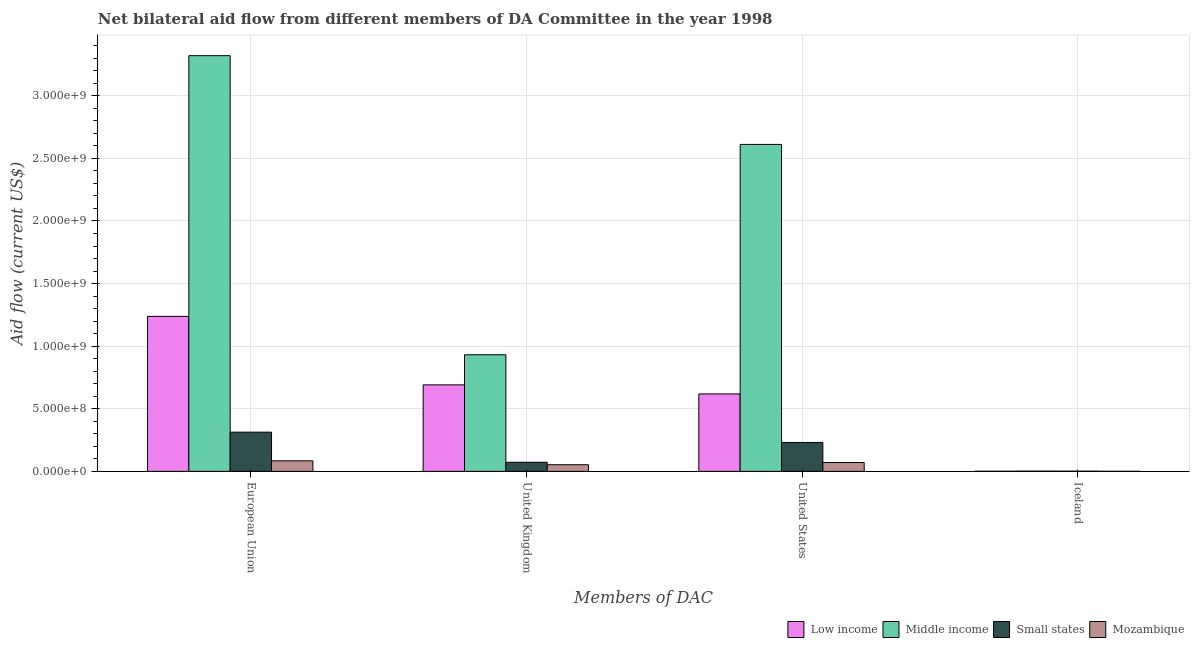How many groups of bars are there?
Offer a very short reply. 4. Are the number of bars per tick equal to the number of legend labels?
Provide a short and direct response. Yes. Are the number of bars on each tick of the X-axis equal?
Offer a very short reply. Yes. How many bars are there on the 4th tick from the left?
Keep it short and to the point. 4. What is the amount of aid given by iceland in Mozambique?
Offer a terse response. 3.90e+05. Across all countries, what is the maximum amount of aid given by us?
Keep it short and to the point. 2.61e+09. Across all countries, what is the minimum amount of aid given by us?
Your answer should be compact. 7.04e+07. In which country was the amount of aid given by us maximum?
Offer a terse response. Middle income. In which country was the amount of aid given by us minimum?
Offer a terse response. Mozambique. What is the total amount of aid given by uk in the graph?
Offer a very short reply. 1.75e+09. What is the difference between the amount of aid given by iceland in Mozambique and that in Middle income?
Offer a very short reply. -1.32e+06. What is the difference between the amount of aid given by eu in Small states and the amount of aid given by iceland in Mozambique?
Your answer should be compact. 3.13e+08. What is the average amount of aid given by uk per country?
Provide a short and direct response. 4.37e+08. What is the difference between the amount of aid given by uk and amount of aid given by iceland in Mozambique?
Your answer should be very brief. 5.26e+07. What is the ratio of the amount of aid given by iceland in Low income to that in Mozambique?
Provide a succinct answer. 2.13. Is the difference between the amount of aid given by uk in Mozambique and Small states greater than the difference between the amount of aid given by us in Mozambique and Small states?
Your response must be concise. Yes. What is the difference between the highest and the lowest amount of aid given by uk?
Offer a terse response. 8.78e+08. Is the sum of the amount of aid given by uk in Low income and Middle income greater than the maximum amount of aid given by iceland across all countries?
Ensure brevity in your answer.  Yes. Is it the case that in every country, the sum of the amount of aid given by uk and amount of aid given by us is greater than the sum of amount of aid given by eu and amount of aid given by iceland?
Offer a very short reply. No. What does the 3rd bar from the left in European Union represents?
Ensure brevity in your answer.  Small states. What does the 2nd bar from the right in Iceland represents?
Offer a very short reply. Small states. What is the difference between two consecutive major ticks on the Y-axis?
Your response must be concise. 5.00e+08. Are the values on the major ticks of Y-axis written in scientific E-notation?
Your response must be concise. Yes. How many legend labels are there?
Offer a terse response. 4. What is the title of the graph?
Ensure brevity in your answer.  Net bilateral aid flow from different members of DA Committee in the year 1998. What is the label or title of the X-axis?
Your answer should be compact. Members of DAC. What is the Aid flow (current US$) of Low income in European Union?
Your response must be concise. 1.24e+09. What is the Aid flow (current US$) of Middle income in European Union?
Your response must be concise. 3.32e+09. What is the Aid flow (current US$) of Small states in European Union?
Your response must be concise. 3.13e+08. What is the Aid flow (current US$) in Mozambique in European Union?
Your response must be concise. 8.41e+07. What is the Aid flow (current US$) in Low income in United Kingdom?
Make the answer very short. 6.91e+08. What is the Aid flow (current US$) in Middle income in United Kingdom?
Provide a succinct answer. 9.31e+08. What is the Aid flow (current US$) of Small states in United Kingdom?
Provide a succinct answer. 7.27e+07. What is the Aid flow (current US$) in Mozambique in United Kingdom?
Give a very brief answer. 5.30e+07. What is the Aid flow (current US$) of Low income in United States?
Provide a short and direct response. 6.19e+08. What is the Aid flow (current US$) of Middle income in United States?
Make the answer very short. 2.61e+09. What is the Aid flow (current US$) of Small states in United States?
Provide a succinct answer. 2.31e+08. What is the Aid flow (current US$) in Mozambique in United States?
Offer a terse response. 7.04e+07. What is the Aid flow (current US$) in Low income in Iceland?
Provide a short and direct response. 8.30e+05. What is the Aid flow (current US$) of Middle income in Iceland?
Your answer should be very brief. 1.71e+06. What is the Aid flow (current US$) of Small states in Iceland?
Ensure brevity in your answer.  1.29e+06. What is the Aid flow (current US$) of Mozambique in Iceland?
Give a very brief answer. 3.90e+05. Across all Members of DAC, what is the maximum Aid flow (current US$) of Low income?
Your answer should be very brief. 1.24e+09. Across all Members of DAC, what is the maximum Aid flow (current US$) of Middle income?
Provide a succinct answer. 3.32e+09. Across all Members of DAC, what is the maximum Aid flow (current US$) of Small states?
Provide a succinct answer. 3.13e+08. Across all Members of DAC, what is the maximum Aid flow (current US$) of Mozambique?
Offer a very short reply. 8.41e+07. Across all Members of DAC, what is the minimum Aid flow (current US$) of Low income?
Your response must be concise. 8.30e+05. Across all Members of DAC, what is the minimum Aid flow (current US$) in Middle income?
Provide a short and direct response. 1.71e+06. Across all Members of DAC, what is the minimum Aid flow (current US$) of Small states?
Make the answer very short. 1.29e+06. Across all Members of DAC, what is the minimum Aid flow (current US$) in Mozambique?
Offer a terse response. 3.90e+05. What is the total Aid flow (current US$) in Low income in the graph?
Your answer should be very brief. 2.55e+09. What is the total Aid flow (current US$) in Middle income in the graph?
Ensure brevity in your answer.  6.87e+09. What is the total Aid flow (current US$) in Small states in the graph?
Provide a short and direct response. 6.18e+08. What is the total Aid flow (current US$) in Mozambique in the graph?
Keep it short and to the point. 2.08e+08. What is the difference between the Aid flow (current US$) of Low income in European Union and that in United Kingdom?
Your response must be concise. 5.47e+08. What is the difference between the Aid flow (current US$) of Middle income in European Union and that in United Kingdom?
Keep it short and to the point. 2.39e+09. What is the difference between the Aid flow (current US$) of Small states in European Union and that in United Kingdom?
Your answer should be compact. 2.41e+08. What is the difference between the Aid flow (current US$) in Mozambique in European Union and that in United Kingdom?
Give a very brief answer. 3.11e+07. What is the difference between the Aid flow (current US$) of Low income in European Union and that in United States?
Your answer should be compact. 6.19e+08. What is the difference between the Aid flow (current US$) in Middle income in European Union and that in United States?
Your response must be concise. 7.09e+08. What is the difference between the Aid flow (current US$) of Small states in European Union and that in United States?
Your answer should be very brief. 8.25e+07. What is the difference between the Aid flow (current US$) in Mozambique in European Union and that in United States?
Offer a very short reply. 1.36e+07. What is the difference between the Aid flow (current US$) in Low income in European Union and that in Iceland?
Offer a very short reply. 1.24e+09. What is the difference between the Aid flow (current US$) of Middle income in European Union and that in Iceland?
Ensure brevity in your answer.  3.32e+09. What is the difference between the Aid flow (current US$) of Small states in European Union and that in Iceland?
Offer a terse response. 3.12e+08. What is the difference between the Aid flow (current US$) in Mozambique in European Union and that in Iceland?
Your answer should be compact. 8.37e+07. What is the difference between the Aid flow (current US$) in Low income in United Kingdom and that in United States?
Your answer should be compact. 7.24e+07. What is the difference between the Aid flow (current US$) in Middle income in United Kingdom and that in United States?
Offer a very short reply. -1.68e+09. What is the difference between the Aid flow (current US$) in Small states in United Kingdom and that in United States?
Provide a short and direct response. -1.58e+08. What is the difference between the Aid flow (current US$) in Mozambique in United Kingdom and that in United States?
Your answer should be very brief. -1.75e+07. What is the difference between the Aid flow (current US$) of Low income in United Kingdom and that in Iceland?
Your response must be concise. 6.90e+08. What is the difference between the Aid flow (current US$) of Middle income in United Kingdom and that in Iceland?
Provide a short and direct response. 9.30e+08. What is the difference between the Aid flow (current US$) in Small states in United Kingdom and that in Iceland?
Your answer should be very brief. 7.14e+07. What is the difference between the Aid flow (current US$) in Mozambique in United Kingdom and that in Iceland?
Your answer should be compact. 5.26e+07. What is the difference between the Aid flow (current US$) of Low income in United States and that in Iceland?
Your answer should be very brief. 6.18e+08. What is the difference between the Aid flow (current US$) in Middle income in United States and that in Iceland?
Your answer should be compact. 2.61e+09. What is the difference between the Aid flow (current US$) of Small states in United States and that in Iceland?
Your answer should be compact. 2.29e+08. What is the difference between the Aid flow (current US$) of Mozambique in United States and that in Iceland?
Give a very brief answer. 7.01e+07. What is the difference between the Aid flow (current US$) in Low income in European Union and the Aid flow (current US$) in Middle income in United Kingdom?
Give a very brief answer. 3.07e+08. What is the difference between the Aid flow (current US$) of Low income in European Union and the Aid flow (current US$) of Small states in United Kingdom?
Offer a very short reply. 1.17e+09. What is the difference between the Aid flow (current US$) of Low income in European Union and the Aid flow (current US$) of Mozambique in United Kingdom?
Provide a short and direct response. 1.18e+09. What is the difference between the Aid flow (current US$) of Middle income in European Union and the Aid flow (current US$) of Small states in United Kingdom?
Ensure brevity in your answer.  3.25e+09. What is the difference between the Aid flow (current US$) in Middle income in European Union and the Aid flow (current US$) in Mozambique in United Kingdom?
Keep it short and to the point. 3.27e+09. What is the difference between the Aid flow (current US$) of Small states in European Union and the Aid flow (current US$) of Mozambique in United Kingdom?
Offer a terse response. 2.60e+08. What is the difference between the Aid flow (current US$) of Low income in European Union and the Aid flow (current US$) of Middle income in United States?
Offer a terse response. -1.37e+09. What is the difference between the Aid flow (current US$) in Low income in European Union and the Aid flow (current US$) in Small states in United States?
Your answer should be compact. 1.01e+09. What is the difference between the Aid flow (current US$) of Low income in European Union and the Aid flow (current US$) of Mozambique in United States?
Your answer should be compact. 1.17e+09. What is the difference between the Aid flow (current US$) of Middle income in European Union and the Aid flow (current US$) of Small states in United States?
Ensure brevity in your answer.  3.09e+09. What is the difference between the Aid flow (current US$) in Middle income in European Union and the Aid flow (current US$) in Mozambique in United States?
Ensure brevity in your answer.  3.25e+09. What is the difference between the Aid flow (current US$) of Small states in European Union and the Aid flow (current US$) of Mozambique in United States?
Your response must be concise. 2.43e+08. What is the difference between the Aid flow (current US$) of Low income in European Union and the Aid flow (current US$) of Middle income in Iceland?
Provide a short and direct response. 1.24e+09. What is the difference between the Aid flow (current US$) in Low income in European Union and the Aid flow (current US$) in Small states in Iceland?
Give a very brief answer. 1.24e+09. What is the difference between the Aid flow (current US$) in Low income in European Union and the Aid flow (current US$) in Mozambique in Iceland?
Provide a succinct answer. 1.24e+09. What is the difference between the Aid flow (current US$) in Middle income in European Union and the Aid flow (current US$) in Small states in Iceland?
Make the answer very short. 3.32e+09. What is the difference between the Aid flow (current US$) of Middle income in European Union and the Aid flow (current US$) of Mozambique in Iceland?
Your response must be concise. 3.32e+09. What is the difference between the Aid flow (current US$) of Small states in European Union and the Aid flow (current US$) of Mozambique in Iceland?
Your answer should be very brief. 3.13e+08. What is the difference between the Aid flow (current US$) in Low income in United Kingdom and the Aid flow (current US$) in Middle income in United States?
Ensure brevity in your answer.  -1.92e+09. What is the difference between the Aid flow (current US$) in Low income in United Kingdom and the Aid flow (current US$) in Small states in United States?
Your answer should be very brief. 4.60e+08. What is the difference between the Aid flow (current US$) in Low income in United Kingdom and the Aid flow (current US$) in Mozambique in United States?
Make the answer very short. 6.21e+08. What is the difference between the Aid flow (current US$) of Middle income in United Kingdom and the Aid flow (current US$) of Small states in United States?
Offer a very short reply. 7.01e+08. What is the difference between the Aid flow (current US$) in Middle income in United Kingdom and the Aid flow (current US$) in Mozambique in United States?
Make the answer very short. 8.61e+08. What is the difference between the Aid flow (current US$) in Small states in United Kingdom and the Aid flow (current US$) in Mozambique in United States?
Make the answer very short. 2.25e+06. What is the difference between the Aid flow (current US$) of Low income in United Kingdom and the Aid flow (current US$) of Middle income in Iceland?
Offer a terse response. 6.89e+08. What is the difference between the Aid flow (current US$) in Low income in United Kingdom and the Aid flow (current US$) in Small states in Iceland?
Make the answer very short. 6.90e+08. What is the difference between the Aid flow (current US$) in Low income in United Kingdom and the Aid flow (current US$) in Mozambique in Iceland?
Keep it short and to the point. 6.91e+08. What is the difference between the Aid flow (current US$) of Middle income in United Kingdom and the Aid flow (current US$) of Small states in Iceland?
Offer a terse response. 9.30e+08. What is the difference between the Aid flow (current US$) in Middle income in United Kingdom and the Aid flow (current US$) in Mozambique in Iceland?
Your response must be concise. 9.31e+08. What is the difference between the Aid flow (current US$) of Small states in United Kingdom and the Aid flow (current US$) of Mozambique in Iceland?
Your answer should be very brief. 7.23e+07. What is the difference between the Aid flow (current US$) of Low income in United States and the Aid flow (current US$) of Middle income in Iceland?
Your answer should be very brief. 6.17e+08. What is the difference between the Aid flow (current US$) in Low income in United States and the Aid flow (current US$) in Small states in Iceland?
Ensure brevity in your answer.  6.17e+08. What is the difference between the Aid flow (current US$) in Low income in United States and the Aid flow (current US$) in Mozambique in Iceland?
Your answer should be very brief. 6.18e+08. What is the difference between the Aid flow (current US$) of Middle income in United States and the Aid flow (current US$) of Small states in Iceland?
Make the answer very short. 2.61e+09. What is the difference between the Aid flow (current US$) of Middle income in United States and the Aid flow (current US$) of Mozambique in Iceland?
Provide a succinct answer. 2.61e+09. What is the difference between the Aid flow (current US$) in Small states in United States and the Aid flow (current US$) in Mozambique in Iceland?
Make the answer very short. 2.30e+08. What is the average Aid flow (current US$) of Low income per Members of DAC?
Keep it short and to the point. 6.37e+08. What is the average Aid flow (current US$) of Middle income per Members of DAC?
Make the answer very short. 1.72e+09. What is the average Aid flow (current US$) of Small states per Members of DAC?
Your answer should be compact. 1.54e+08. What is the average Aid flow (current US$) of Mozambique per Members of DAC?
Your response must be concise. 5.20e+07. What is the difference between the Aid flow (current US$) in Low income and Aid flow (current US$) in Middle income in European Union?
Your answer should be compact. -2.08e+09. What is the difference between the Aid flow (current US$) of Low income and Aid flow (current US$) of Small states in European Union?
Provide a short and direct response. 9.25e+08. What is the difference between the Aid flow (current US$) in Low income and Aid flow (current US$) in Mozambique in European Union?
Keep it short and to the point. 1.15e+09. What is the difference between the Aid flow (current US$) in Middle income and Aid flow (current US$) in Small states in European Union?
Keep it short and to the point. 3.01e+09. What is the difference between the Aid flow (current US$) in Middle income and Aid flow (current US$) in Mozambique in European Union?
Keep it short and to the point. 3.24e+09. What is the difference between the Aid flow (current US$) of Small states and Aid flow (current US$) of Mozambique in European Union?
Give a very brief answer. 2.29e+08. What is the difference between the Aid flow (current US$) in Low income and Aid flow (current US$) in Middle income in United Kingdom?
Your response must be concise. -2.40e+08. What is the difference between the Aid flow (current US$) in Low income and Aid flow (current US$) in Small states in United Kingdom?
Ensure brevity in your answer.  6.18e+08. What is the difference between the Aid flow (current US$) of Low income and Aid flow (current US$) of Mozambique in United Kingdom?
Provide a short and direct response. 6.38e+08. What is the difference between the Aid flow (current US$) of Middle income and Aid flow (current US$) of Small states in United Kingdom?
Ensure brevity in your answer.  8.59e+08. What is the difference between the Aid flow (current US$) in Middle income and Aid flow (current US$) in Mozambique in United Kingdom?
Your response must be concise. 8.78e+08. What is the difference between the Aid flow (current US$) in Small states and Aid flow (current US$) in Mozambique in United Kingdom?
Provide a short and direct response. 1.98e+07. What is the difference between the Aid flow (current US$) in Low income and Aid flow (current US$) in Middle income in United States?
Provide a succinct answer. -1.99e+09. What is the difference between the Aid flow (current US$) in Low income and Aid flow (current US$) in Small states in United States?
Make the answer very short. 3.88e+08. What is the difference between the Aid flow (current US$) in Low income and Aid flow (current US$) in Mozambique in United States?
Provide a succinct answer. 5.48e+08. What is the difference between the Aid flow (current US$) in Middle income and Aid flow (current US$) in Small states in United States?
Keep it short and to the point. 2.38e+09. What is the difference between the Aid flow (current US$) in Middle income and Aid flow (current US$) in Mozambique in United States?
Ensure brevity in your answer.  2.54e+09. What is the difference between the Aid flow (current US$) of Small states and Aid flow (current US$) of Mozambique in United States?
Keep it short and to the point. 1.60e+08. What is the difference between the Aid flow (current US$) in Low income and Aid flow (current US$) in Middle income in Iceland?
Provide a succinct answer. -8.80e+05. What is the difference between the Aid flow (current US$) in Low income and Aid flow (current US$) in Small states in Iceland?
Your answer should be very brief. -4.60e+05. What is the difference between the Aid flow (current US$) of Low income and Aid flow (current US$) of Mozambique in Iceland?
Provide a short and direct response. 4.40e+05. What is the difference between the Aid flow (current US$) in Middle income and Aid flow (current US$) in Small states in Iceland?
Ensure brevity in your answer.  4.20e+05. What is the difference between the Aid flow (current US$) in Middle income and Aid flow (current US$) in Mozambique in Iceland?
Your answer should be compact. 1.32e+06. What is the ratio of the Aid flow (current US$) of Low income in European Union to that in United Kingdom?
Give a very brief answer. 1.79. What is the ratio of the Aid flow (current US$) of Middle income in European Union to that in United Kingdom?
Make the answer very short. 3.57. What is the ratio of the Aid flow (current US$) in Small states in European Union to that in United Kingdom?
Your response must be concise. 4.31. What is the ratio of the Aid flow (current US$) in Mozambique in European Union to that in United Kingdom?
Provide a succinct answer. 1.59. What is the ratio of the Aid flow (current US$) of Low income in European Union to that in United States?
Your response must be concise. 2. What is the ratio of the Aid flow (current US$) in Middle income in European Union to that in United States?
Provide a succinct answer. 1.27. What is the ratio of the Aid flow (current US$) of Small states in European Union to that in United States?
Your response must be concise. 1.36. What is the ratio of the Aid flow (current US$) of Mozambique in European Union to that in United States?
Your answer should be compact. 1.19. What is the ratio of the Aid flow (current US$) of Low income in European Union to that in Iceland?
Ensure brevity in your answer.  1491.43. What is the ratio of the Aid flow (current US$) of Middle income in European Union to that in Iceland?
Provide a short and direct response. 1941.82. What is the ratio of the Aid flow (current US$) in Small states in European Union to that in Iceland?
Ensure brevity in your answer.  242.81. What is the ratio of the Aid flow (current US$) in Mozambique in European Union to that in Iceland?
Provide a short and direct response. 215.62. What is the ratio of the Aid flow (current US$) of Low income in United Kingdom to that in United States?
Provide a short and direct response. 1.12. What is the ratio of the Aid flow (current US$) in Middle income in United Kingdom to that in United States?
Provide a succinct answer. 0.36. What is the ratio of the Aid flow (current US$) in Small states in United Kingdom to that in United States?
Give a very brief answer. 0.32. What is the ratio of the Aid flow (current US$) in Mozambique in United Kingdom to that in United States?
Make the answer very short. 0.75. What is the ratio of the Aid flow (current US$) of Low income in United Kingdom to that in Iceland?
Give a very brief answer. 832.48. What is the ratio of the Aid flow (current US$) of Middle income in United Kingdom to that in Iceland?
Keep it short and to the point. 544.63. What is the ratio of the Aid flow (current US$) of Small states in United Kingdom to that in Iceland?
Your response must be concise. 56.36. What is the ratio of the Aid flow (current US$) in Mozambique in United Kingdom to that in Iceland?
Your answer should be very brief. 135.77. What is the ratio of the Aid flow (current US$) of Low income in United States to that in Iceland?
Your answer should be very brief. 745.25. What is the ratio of the Aid flow (current US$) in Middle income in United States to that in Iceland?
Provide a short and direct response. 1527.23. What is the ratio of the Aid flow (current US$) of Small states in United States to that in Iceland?
Your response must be concise. 178.85. What is the ratio of the Aid flow (current US$) of Mozambique in United States to that in Iceland?
Offer a very short reply. 180.64. What is the difference between the highest and the second highest Aid flow (current US$) in Low income?
Offer a very short reply. 5.47e+08. What is the difference between the highest and the second highest Aid flow (current US$) in Middle income?
Make the answer very short. 7.09e+08. What is the difference between the highest and the second highest Aid flow (current US$) of Small states?
Your answer should be compact. 8.25e+07. What is the difference between the highest and the second highest Aid flow (current US$) in Mozambique?
Keep it short and to the point. 1.36e+07. What is the difference between the highest and the lowest Aid flow (current US$) in Low income?
Make the answer very short. 1.24e+09. What is the difference between the highest and the lowest Aid flow (current US$) of Middle income?
Make the answer very short. 3.32e+09. What is the difference between the highest and the lowest Aid flow (current US$) in Small states?
Your answer should be very brief. 3.12e+08. What is the difference between the highest and the lowest Aid flow (current US$) in Mozambique?
Make the answer very short. 8.37e+07. 